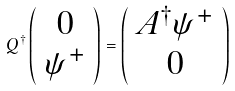<formula> <loc_0><loc_0><loc_500><loc_500>Q ^ { \dagger } \left ( \begin{array} { c } 0 \\ \psi ^ { + } \end{array} \right ) = \left ( \begin{array} { c } A ^ { \dagger } \psi ^ { + } \\ 0 \end{array} \right )</formula> 